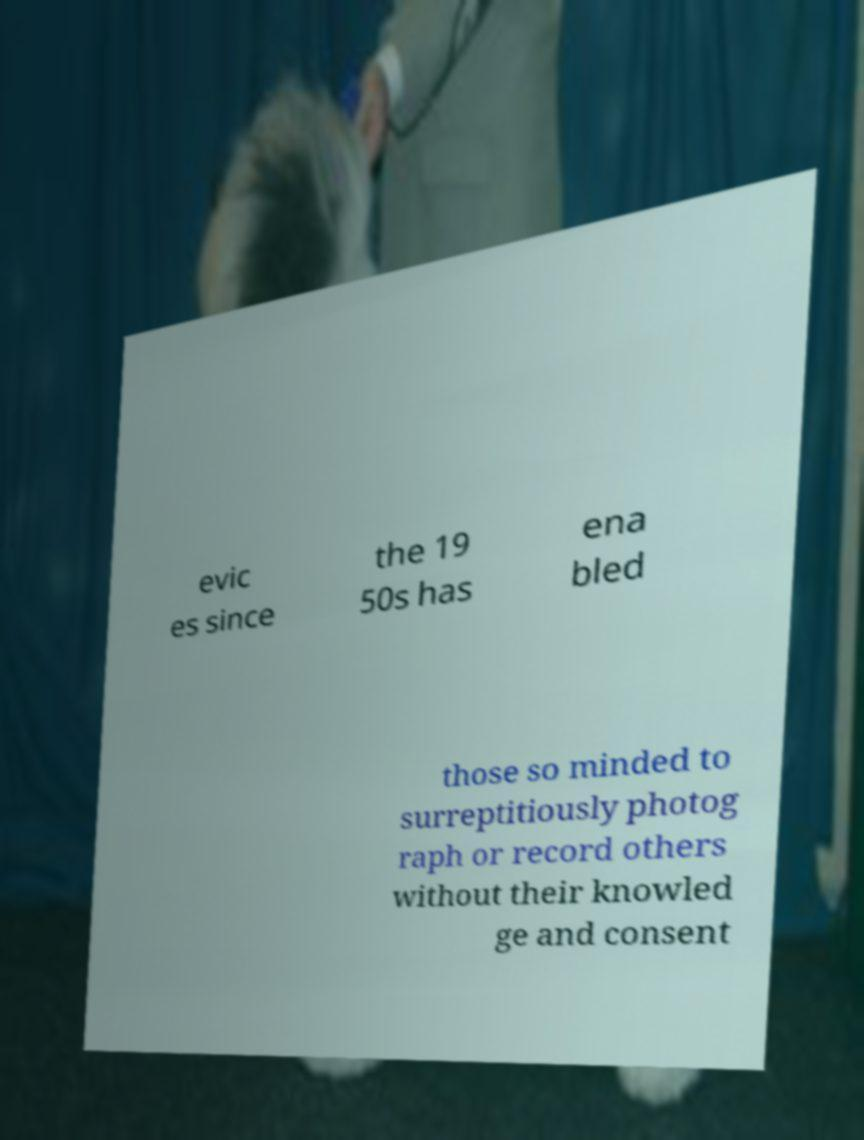Could you assist in decoding the text presented in this image and type it out clearly? evic es since the 19 50s has ena bled those so minded to surreptitiously photog raph or record others without their knowled ge and consent 